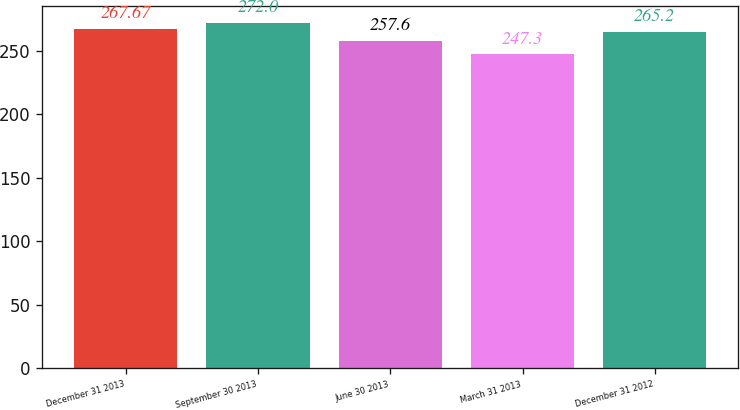Convert chart to OTSL. <chart><loc_0><loc_0><loc_500><loc_500><bar_chart><fcel>December 31 2013<fcel>September 30 2013<fcel>June 30 2013<fcel>March 31 2013<fcel>December 31 2012<nl><fcel>267.67<fcel>272<fcel>257.6<fcel>247.3<fcel>265.2<nl></chart> 